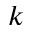Convert formula to latex. <formula><loc_0><loc_0><loc_500><loc_500>k</formula> 